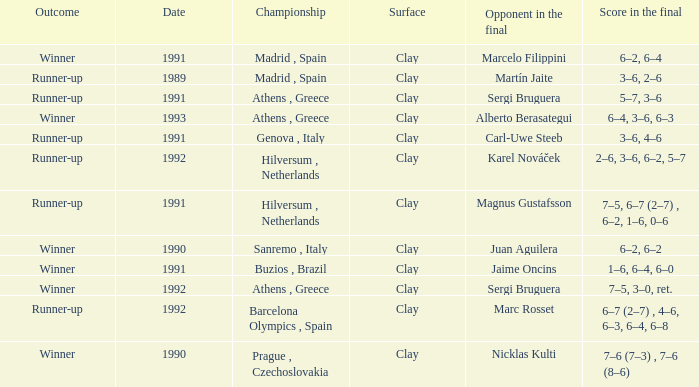What is Opponent In The Final, when Date is before 1991, and when Outcome is "Runner-Up"? Martín Jaite. 